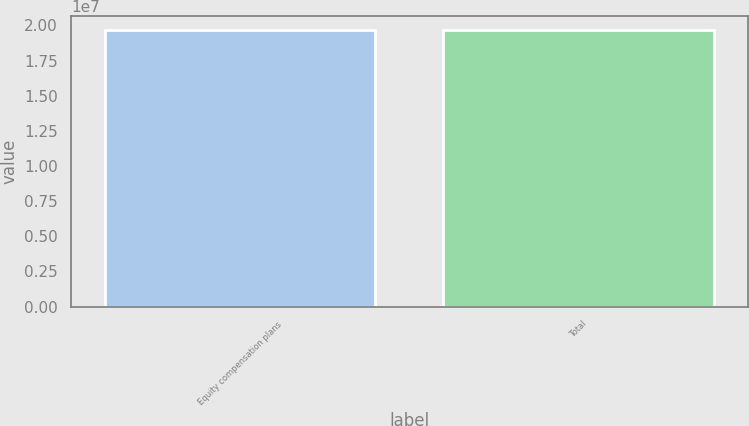<chart> <loc_0><loc_0><loc_500><loc_500><bar_chart><fcel>Equity compensation plans<fcel>Total<nl><fcel>1.96774e+07<fcel>1.96774e+07<nl></chart> 